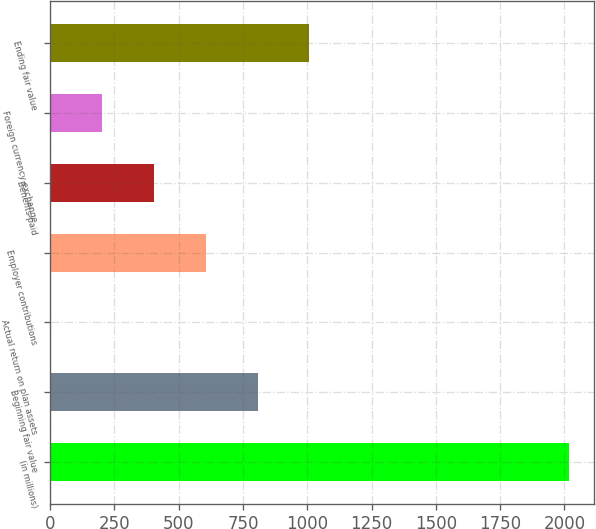Convert chart to OTSL. <chart><loc_0><loc_0><loc_500><loc_500><bar_chart><fcel>(in millions)<fcel>Beginning fair value<fcel>Actual return on plan assets<fcel>Employer contributions<fcel>Benefits paid<fcel>Foreign currency exchange<fcel>Ending fair value<nl><fcel>2016<fcel>807<fcel>1<fcel>605.5<fcel>404<fcel>202.5<fcel>1008.5<nl></chart> 